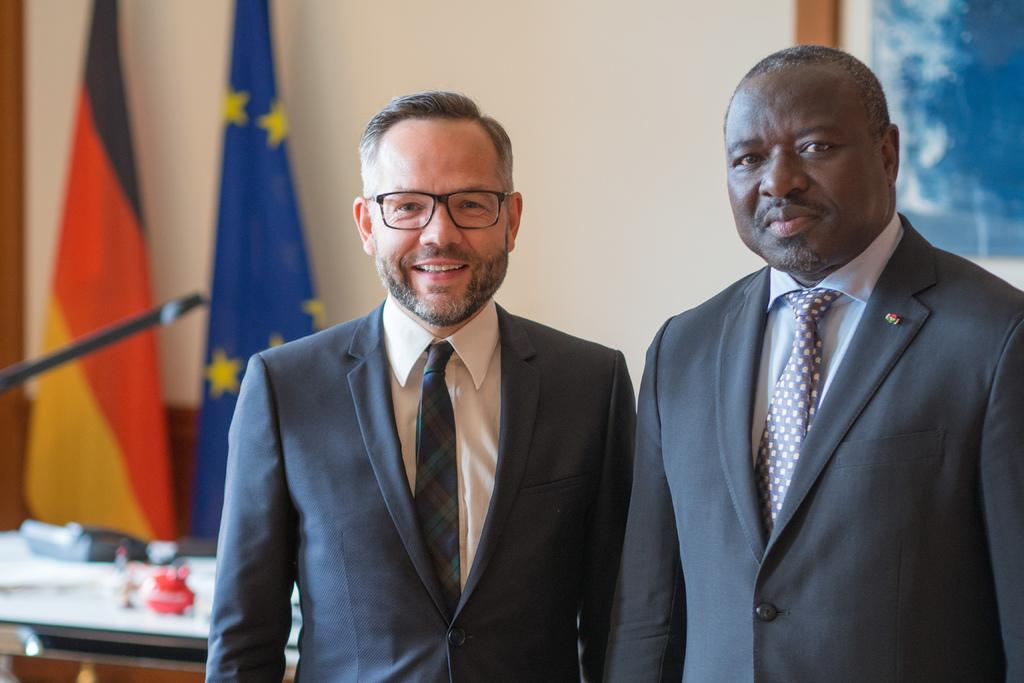Who or what can be seen in the image? There are people in the image. What are the people doing in the image? The people are standing and smiling. What else can be seen in the background of the image? There are other objects in the background of the image. What type of flesh can be seen on the people in the image? There is no mention of flesh or any specific body parts in the image, so it cannot be determined from the image. 